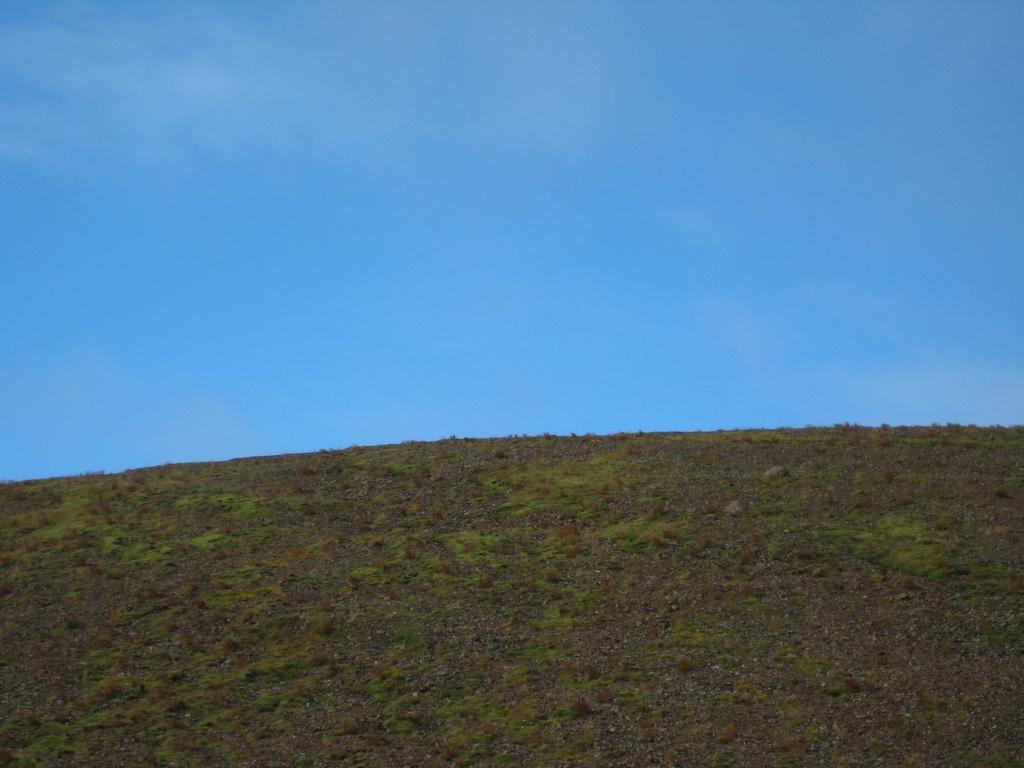Can you describe this image briefly? In this picture we can see grass on the ground and we can see sky in the background. 